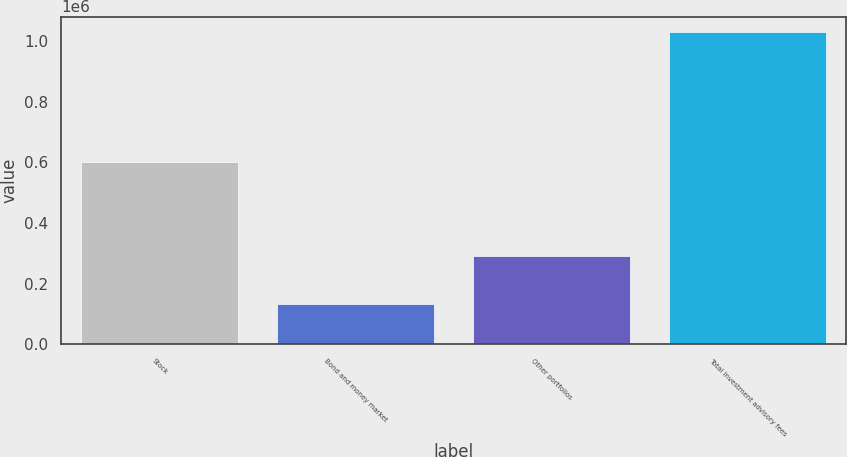Convert chart. <chart><loc_0><loc_0><loc_500><loc_500><bar_chart><fcel>Stock<fcel>Bond and money market<fcel>Other portfolios<fcel>Total investment advisory fees<nl><fcel>602220<fcel>133953<fcel>292658<fcel>1.02883e+06<nl></chart> 